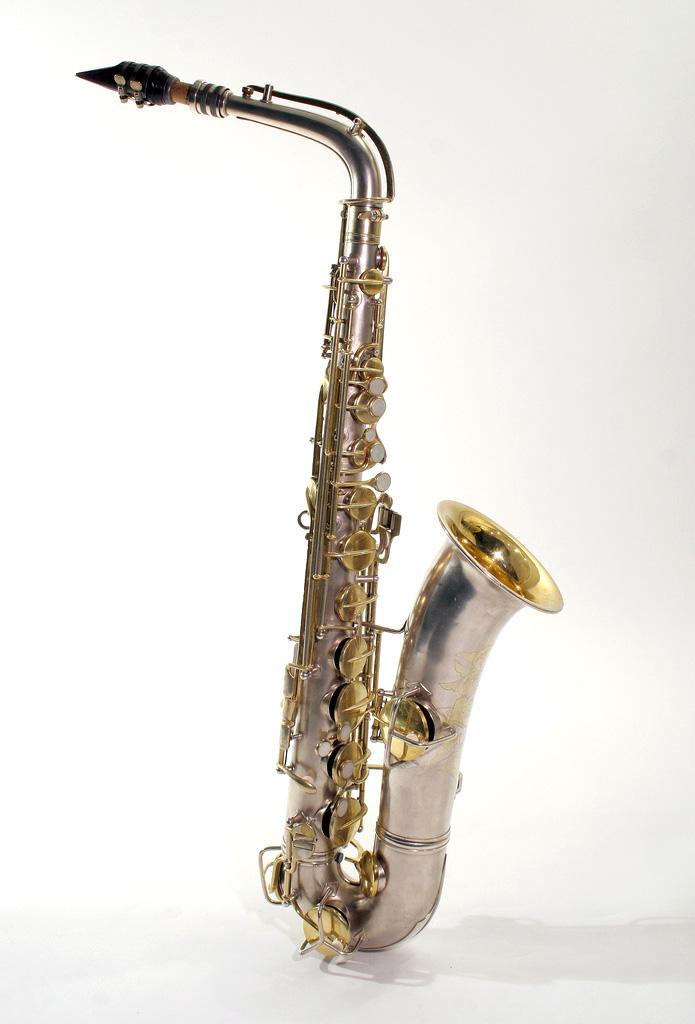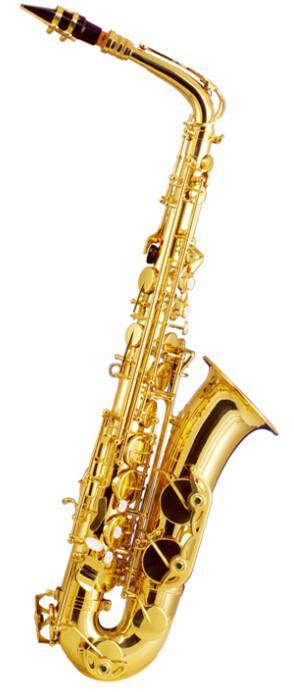The first image is the image on the left, the second image is the image on the right. Assess this claim about the two images: "The left-hand instrument is vertical with a silver body.". Correct or not? Answer yes or no. Yes. 